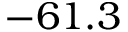Convert formula to latex. <formula><loc_0><loc_0><loc_500><loc_500>- 6 1 . 3</formula> 